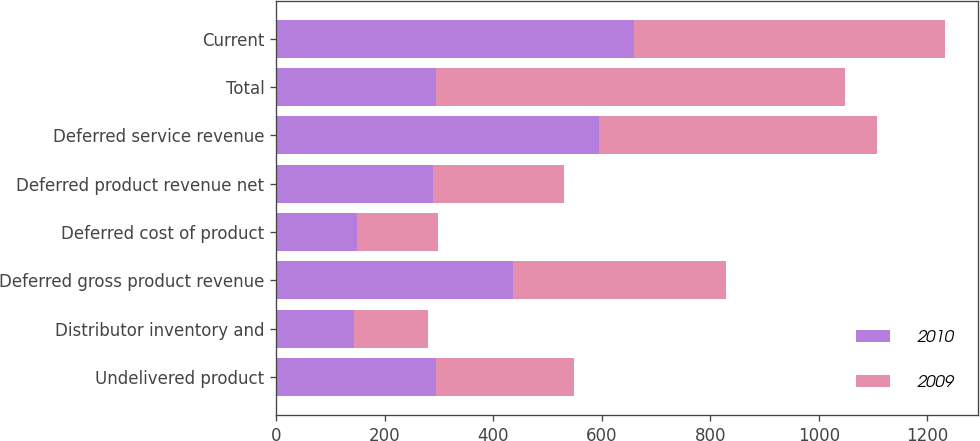<chart> <loc_0><loc_0><loc_500><loc_500><stacked_bar_chart><ecel><fcel>Undelivered product<fcel>Distributor inventory and<fcel>Deferred gross product revenue<fcel>Deferred cost of product<fcel>Deferred product revenue net<fcel>Deferred service revenue<fcel>Total<fcel>Current<nl><fcel>2010<fcel>294.1<fcel>143.4<fcel>437.5<fcel>148.8<fcel>288.7<fcel>595.7<fcel>294.1<fcel>660.2<nl><fcel>2009<fcel>254.7<fcel>136.6<fcel>391.3<fcel>150<fcel>241.3<fcel>512.3<fcel>753.6<fcel>571.7<nl></chart> 